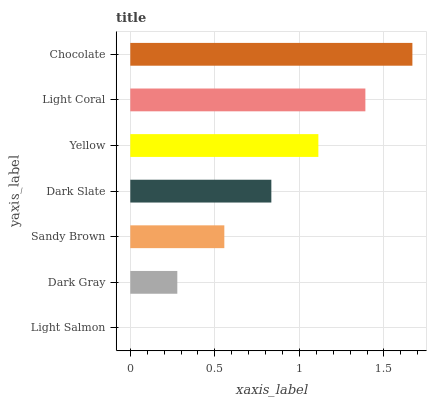Is Light Salmon the minimum?
Answer yes or no. Yes. Is Chocolate the maximum?
Answer yes or no. Yes. Is Dark Gray the minimum?
Answer yes or no. No. Is Dark Gray the maximum?
Answer yes or no. No. Is Dark Gray greater than Light Salmon?
Answer yes or no. Yes. Is Light Salmon less than Dark Gray?
Answer yes or no. Yes. Is Light Salmon greater than Dark Gray?
Answer yes or no. No. Is Dark Gray less than Light Salmon?
Answer yes or no. No. Is Dark Slate the high median?
Answer yes or no. Yes. Is Dark Slate the low median?
Answer yes or no. Yes. Is Sandy Brown the high median?
Answer yes or no. No. Is Yellow the low median?
Answer yes or no. No. 